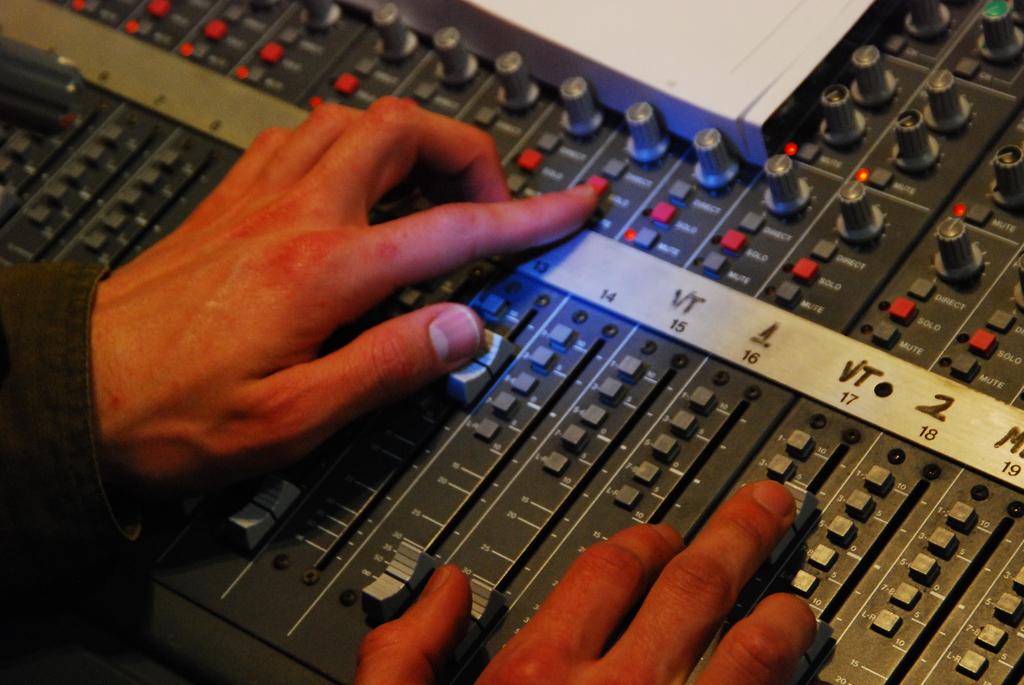What is the label for channel 17?
Give a very brief answer. Vt. What number is under the label saying 2?
Ensure brevity in your answer.  18. 